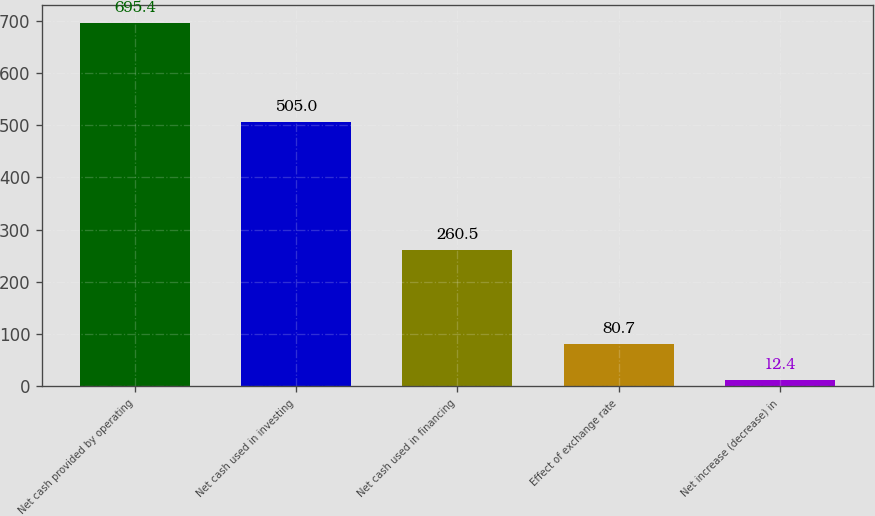<chart> <loc_0><loc_0><loc_500><loc_500><bar_chart><fcel>Net cash provided by operating<fcel>Net cash used in investing<fcel>Net cash used in financing<fcel>Effect of exchange rate<fcel>Net increase (decrease) in<nl><fcel>695.4<fcel>505<fcel>260.5<fcel>80.7<fcel>12.4<nl></chart> 